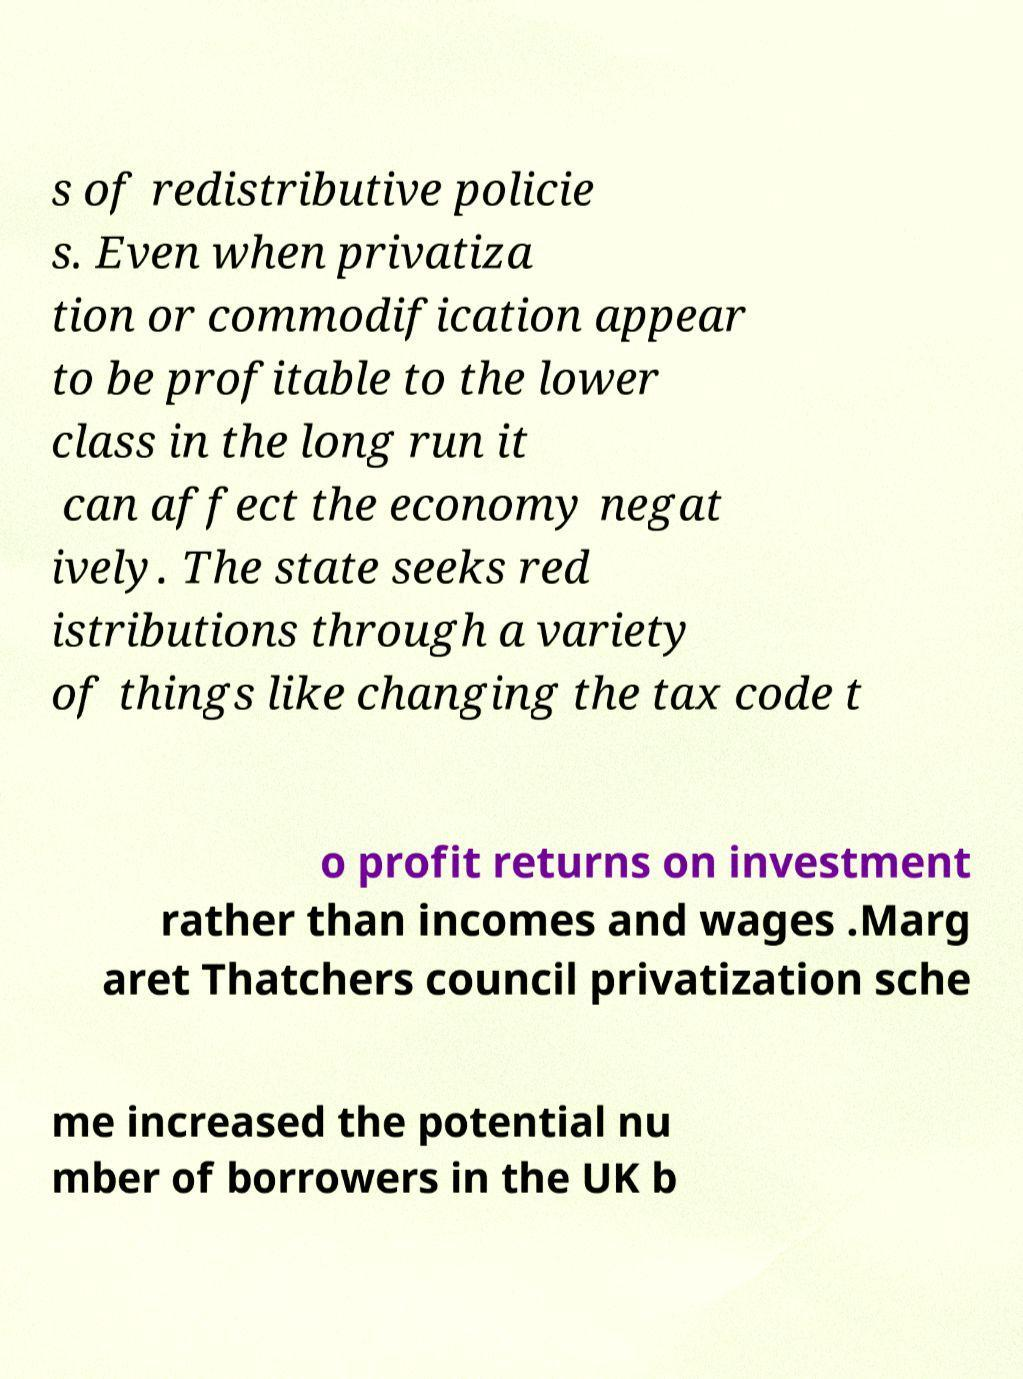Please read and relay the text visible in this image. What does it say? s of redistributive policie s. Even when privatiza tion or commodification appear to be profitable to the lower class in the long run it can affect the economy negat ively. The state seeks red istributions through a variety of things like changing the tax code t o profit returns on investment rather than incomes and wages .Marg aret Thatchers council privatization sche me increased the potential nu mber of borrowers in the UK b 